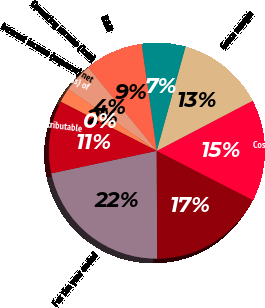Convert chart. <chart><loc_0><loc_0><loc_500><loc_500><pie_chart><fcel>For the year ended<fcel>Net sales<fcel>Cost of goods sold<fcel>Gross margin<fcel>SG&A<fcel>R&D<fcel>Operating income (loss)<fcel>Interest income (expense) net<fcel>Equity in net income (loss) of<fcel>Net income (loss) attributable<nl><fcel>21.73%<fcel>17.38%<fcel>15.21%<fcel>13.04%<fcel>6.53%<fcel>8.7%<fcel>4.35%<fcel>2.18%<fcel>0.01%<fcel>10.87%<nl></chart> 